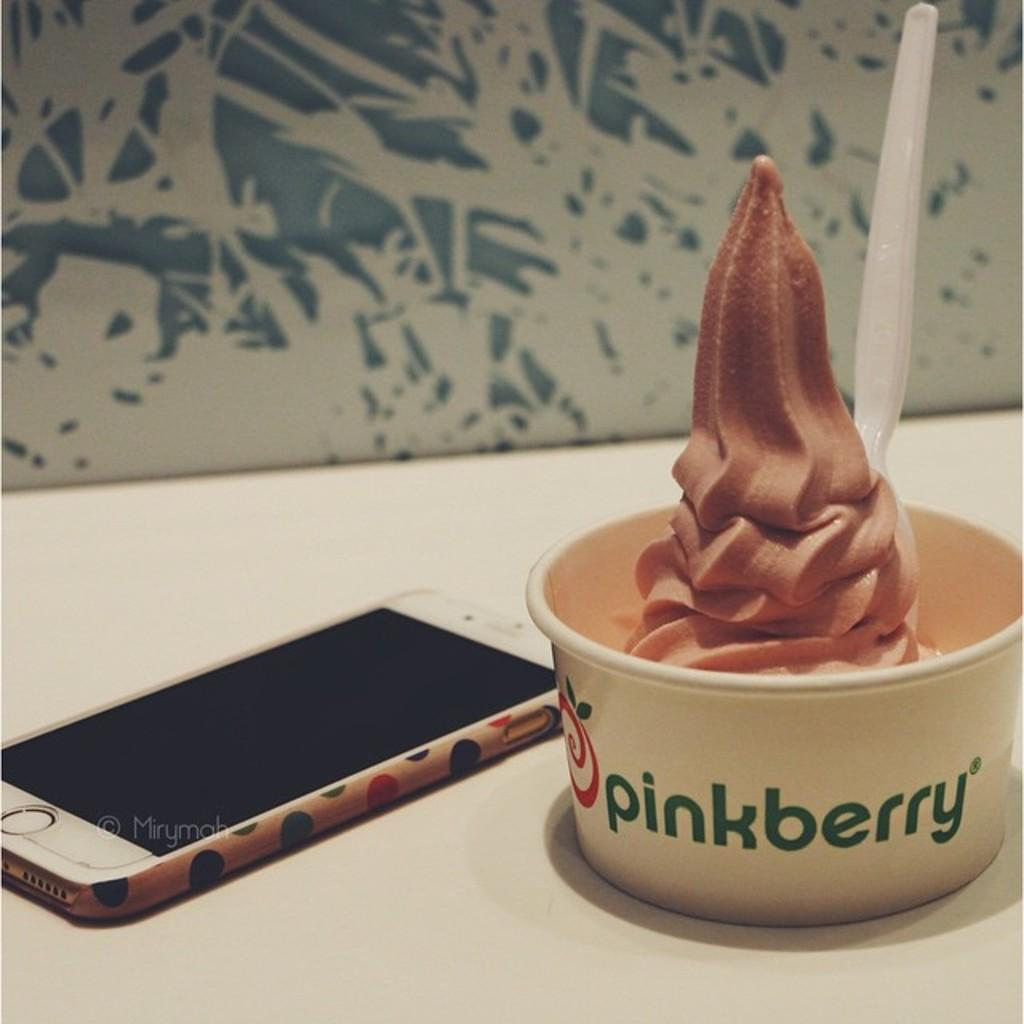What type of food can be seen in the image? The image contains food, but the specific type is not mentioned in the facts. What utensil is present in the cup? There is a spoon in the cup. Can you describe the cup in the image? The cup is visible in the image. What other object can be seen in the image? There is a mobile in the image. What type of punishment is being administered in the image? There is no indication of punishment in the image; it contains food, a spoon, a cup, and a mobile. How many screws are visible in the image? There is no mention of screws in the image; it contains food, a spoon, a cup, and a mobile. 